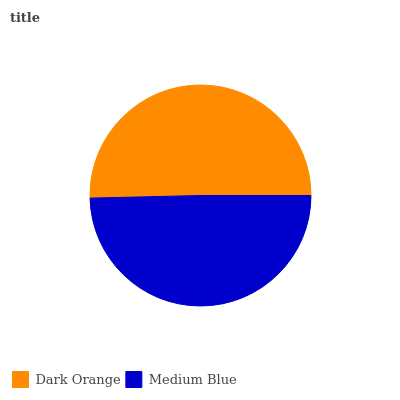Is Medium Blue the minimum?
Answer yes or no. Yes. Is Dark Orange the maximum?
Answer yes or no. Yes. Is Medium Blue the maximum?
Answer yes or no. No. Is Dark Orange greater than Medium Blue?
Answer yes or no. Yes. Is Medium Blue less than Dark Orange?
Answer yes or no. Yes. Is Medium Blue greater than Dark Orange?
Answer yes or no. No. Is Dark Orange less than Medium Blue?
Answer yes or no. No. Is Dark Orange the high median?
Answer yes or no. Yes. Is Medium Blue the low median?
Answer yes or no. Yes. Is Medium Blue the high median?
Answer yes or no. No. Is Dark Orange the low median?
Answer yes or no. No. 